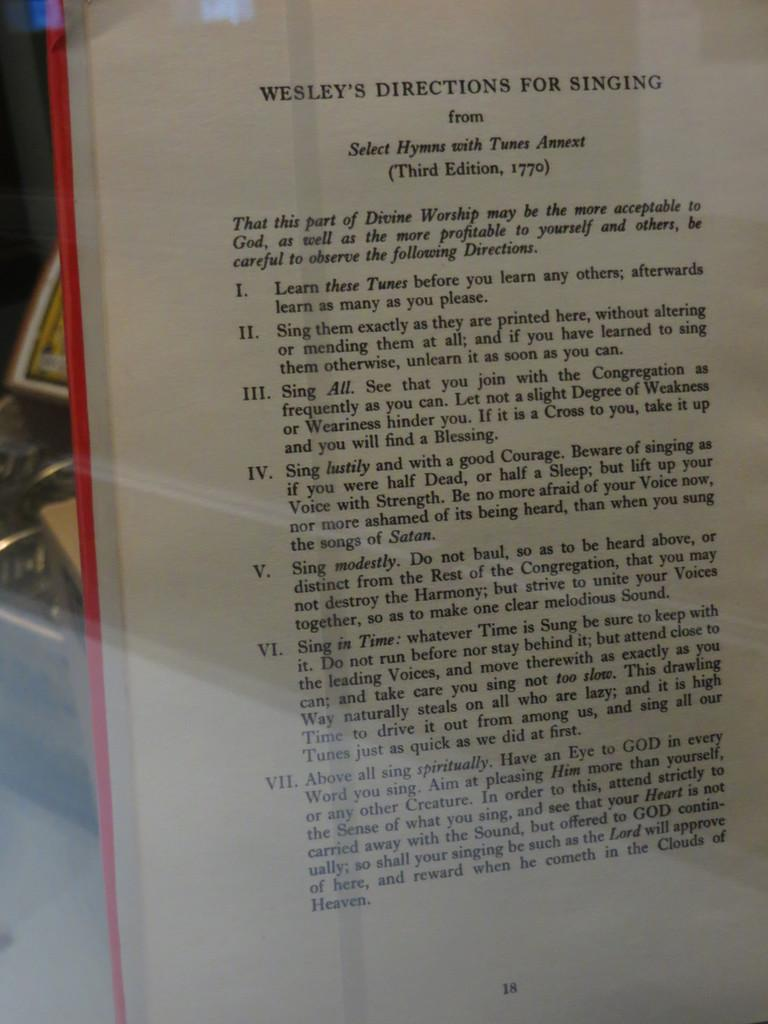<image>
Summarize the visual content of the image. An excerpt from Wesley's Directions for Singing through a glass 